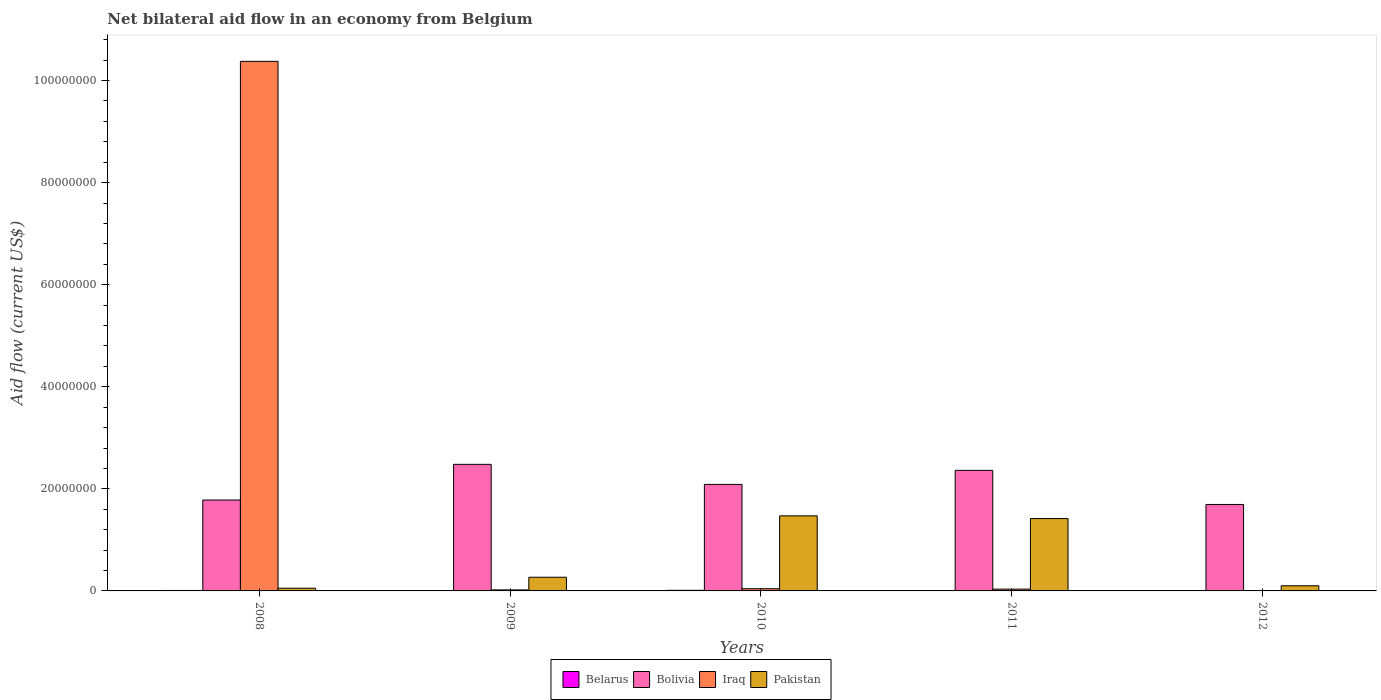How many groups of bars are there?
Provide a short and direct response. 5. Are the number of bars per tick equal to the number of legend labels?
Keep it short and to the point. Yes. Are the number of bars on each tick of the X-axis equal?
Offer a very short reply. Yes. How many bars are there on the 3rd tick from the left?
Give a very brief answer. 4. What is the net bilateral aid flow in Pakistan in 2010?
Offer a terse response. 1.47e+07. Across all years, what is the maximum net bilateral aid flow in Pakistan?
Your answer should be compact. 1.47e+07. Across all years, what is the minimum net bilateral aid flow in Pakistan?
Provide a succinct answer. 5.30e+05. In which year was the net bilateral aid flow in Belarus maximum?
Offer a terse response. 2010. What is the difference between the net bilateral aid flow in Belarus in 2008 and that in 2011?
Make the answer very short. 4.00e+04. What is the difference between the net bilateral aid flow in Bolivia in 2010 and the net bilateral aid flow in Pakistan in 2009?
Offer a terse response. 1.82e+07. What is the average net bilateral aid flow in Bolivia per year?
Give a very brief answer. 2.08e+07. In the year 2009, what is the difference between the net bilateral aid flow in Bolivia and net bilateral aid flow in Pakistan?
Give a very brief answer. 2.21e+07. In how many years, is the net bilateral aid flow in Bolivia greater than 12000000 US$?
Offer a very short reply. 5. Is the difference between the net bilateral aid flow in Bolivia in 2010 and 2012 greater than the difference between the net bilateral aid flow in Pakistan in 2010 and 2012?
Your answer should be compact. No. What is the difference between the highest and the second highest net bilateral aid flow in Pakistan?
Offer a very short reply. 5.30e+05. What is the difference between the highest and the lowest net bilateral aid flow in Pakistan?
Your answer should be compact. 1.42e+07. What does the 2nd bar from the left in 2010 represents?
Make the answer very short. Bolivia. What does the 4th bar from the right in 2009 represents?
Your response must be concise. Belarus. Is it the case that in every year, the sum of the net bilateral aid flow in Belarus and net bilateral aid flow in Bolivia is greater than the net bilateral aid flow in Pakistan?
Your answer should be compact. Yes. How many bars are there?
Your response must be concise. 20. Are all the bars in the graph horizontal?
Make the answer very short. No. How many years are there in the graph?
Offer a very short reply. 5. Does the graph contain grids?
Give a very brief answer. No. Where does the legend appear in the graph?
Your answer should be compact. Bottom center. How many legend labels are there?
Give a very brief answer. 4. What is the title of the graph?
Ensure brevity in your answer.  Net bilateral aid flow in an economy from Belgium. What is the label or title of the X-axis?
Make the answer very short. Years. What is the Aid flow (current US$) of Bolivia in 2008?
Offer a very short reply. 1.78e+07. What is the Aid flow (current US$) in Iraq in 2008?
Provide a short and direct response. 1.04e+08. What is the Aid flow (current US$) of Pakistan in 2008?
Keep it short and to the point. 5.30e+05. What is the Aid flow (current US$) in Bolivia in 2009?
Ensure brevity in your answer.  2.48e+07. What is the Aid flow (current US$) in Pakistan in 2009?
Offer a very short reply. 2.68e+06. What is the Aid flow (current US$) in Bolivia in 2010?
Your answer should be very brief. 2.09e+07. What is the Aid flow (current US$) of Iraq in 2010?
Your response must be concise. 4.30e+05. What is the Aid flow (current US$) of Pakistan in 2010?
Your response must be concise. 1.47e+07. What is the Aid flow (current US$) of Bolivia in 2011?
Keep it short and to the point. 2.36e+07. What is the Aid flow (current US$) in Iraq in 2011?
Keep it short and to the point. 3.50e+05. What is the Aid flow (current US$) of Pakistan in 2011?
Your answer should be very brief. 1.42e+07. What is the Aid flow (current US$) in Belarus in 2012?
Your answer should be very brief. 6.00e+04. What is the Aid flow (current US$) of Bolivia in 2012?
Provide a succinct answer. 1.69e+07. What is the Aid flow (current US$) of Pakistan in 2012?
Make the answer very short. 1.01e+06. Across all years, what is the maximum Aid flow (current US$) of Bolivia?
Your answer should be very brief. 2.48e+07. Across all years, what is the maximum Aid flow (current US$) in Iraq?
Ensure brevity in your answer.  1.04e+08. Across all years, what is the maximum Aid flow (current US$) of Pakistan?
Offer a very short reply. 1.47e+07. Across all years, what is the minimum Aid flow (current US$) in Bolivia?
Your answer should be compact. 1.69e+07. Across all years, what is the minimum Aid flow (current US$) of Pakistan?
Ensure brevity in your answer.  5.30e+05. What is the total Aid flow (current US$) of Belarus in the graph?
Provide a short and direct response. 3.50e+05. What is the total Aid flow (current US$) of Bolivia in the graph?
Your answer should be very brief. 1.04e+08. What is the total Aid flow (current US$) of Iraq in the graph?
Ensure brevity in your answer.  1.05e+08. What is the total Aid flow (current US$) in Pakistan in the graph?
Your response must be concise. 3.31e+07. What is the difference between the Aid flow (current US$) of Belarus in 2008 and that in 2009?
Give a very brief answer. 6.00e+04. What is the difference between the Aid flow (current US$) of Bolivia in 2008 and that in 2009?
Give a very brief answer. -6.99e+06. What is the difference between the Aid flow (current US$) in Iraq in 2008 and that in 2009?
Provide a succinct answer. 1.04e+08. What is the difference between the Aid flow (current US$) in Pakistan in 2008 and that in 2009?
Ensure brevity in your answer.  -2.15e+06. What is the difference between the Aid flow (current US$) in Belarus in 2008 and that in 2010?
Provide a short and direct response. -3.00e+04. What is the difference between the Aid flow (current US$) in Bolivia in 2008 and that in 2010?
Give a very brief answer. -3.06e+06. What is the difference between the Aid flow (current US$) in Iraq in 2008 and that in 2010?
Offer a terse response. 1.03e+08. What is the difference between the Aid flow (current US$) in Pakistan in 2008 and that in 2010?
Ensure brevity in your answer.  -1.42e+07. What is the difference between the Aid flow (current US$) in Bolivia in 2008 and that in 2011?
Keep it short and to the point. -5.81e+06. What is the difference between the Aid flow (current US$) in Iraq in 2008 and that in 2011?
Your response must be concise. 1.03e+08. What is the difference between the Aid flow (current US$) of Pakistan in 2008 and that in 2011?
Provide a succinct answer. -1.36e+07. What is the difference between the Aid flow (current US$) of Belarus in 2008 and that in 2012?
Keep it short and to the point. 3.00e+04. What is the difference between the Aid flow (current US$) in Bolivia in 2008 and that in 2012?
Provide a short and direct response. 8.70e+05. What is the difference between the Aid flow (current US$) in Iraq in 2008 and that in 2012?
Ensure brevity in your answer.  1.04e+08. What is the difference between the Aid flow (current US$) of Pakistan in 2008 and that in 2012?
Ensure brevity in your answer.  -4.80e+05. What is the difference between the Aid flow (current US$) of Belarus in 2009 and that in 2010?
Offer a terse response. -9.00e+04. What is the difference between the Aid flow (current US$) in Bolivia in 2009 and that in 2010?
Offer a terse response. 3.93e+06. What is the difference between the Aid flow (current US$) of Pakistan in 2009 and that in 2010?
Offer a very short reply. -1.20e+07. What is the difference between the Aid flow (current US$) in Bolivia in 2009 and that in 2011?
Your answer should be compact. 1.18e+06. What is the difference between the Aid flow (current US$) in Pakistan in 2009 and that in 2011?
Make the answer very short. -1.15e+07. What is the difference between the Aid flow (current US$) in Belarus in 2009 and that in 2012?
Make the answer very short. -3.00e+04. What is the difference between the Aid flow (current US$) of Bolivia in 2009 and that in 2012?
Provide a short and direct response. 7.86e+06. What is the difference between the Aid flow (current US$) of Pakistan in 2009 and that in 2012?
Offer a very short reply. 1.67e+06. What is the difference between the Aid flow (current US$) in Bolivia in 2010 and that in 2011?
Offer a very short reply. -2.75e+06. What is the difference between the Aid flow (current US$) of Pakistan in 2010 and that in 2011?
Ensure brevity in your answer.  5.30e+05. What is the difference between the Aid flow (current US$) of Belarus in 2010 and that in 2012?
Provide a short and direct response. 6.00e+04. What is the difference between the Aid flow (current US$) in Bolivia in 2010 and that in 2012?
Offer a terse response. 3.93e+06. What is the difference between the Aid flow (current US$) of Iraq in 2010 and that in 2012?
Ensure brevity in your answer.  4.00e+05. What is the difference between the Aid flow (current US$) in Pakistan in 2010 and that in 2012?
Give a very brief answer. 1.37e+07. What is the difference between the Aid flow (current US$) in Bolivia in 2011 and that in 2012?
Provide a succinct answer. 6.68e+06. What is the difference between the Aid flow (current US$) in Iraq in 2011 and that in 2012?
Provide a short and direct response. 3.20e+05. What is the difference between the Aid flow (current US$) of Pakistan in 2011 and that in 2012?
Give a very brief answer. 1.32e+07. What is the difference between the Aid flow (current US$) of Belarus in 2008 and the Aid flow (current US$) of Bolivia in 2009?
Offer a terse response. -2.47e+07. What is the difference between the Aid flow (current US$) of Belarus in 2008 and the Aid flow (current US$) of Iraq in 2009?
Ensure brevity in your answer.  -1.10e+05. What is the difference between the Aid flow (current US$) in Belarus in 2008 and the Aid flow (current US$) in Pakistan in 2009?
Offer a very short reply. -2.59e+06. What is the difference between the Aid flow (current US$) of Bolivia in 2008 and the Aid flow (current US$) of Iraq in 2009?
Your answer should be compact. 1.76e+07. What is the difference between the Aid flow (current US$) in Bolivia in 2008 and the Aid flow (current US$) in Pakistan in 2009?
Make the answer very short. 1.51e+07. What is the difference between the Aid flow (current US$) of Iraq in 2008 and the Aid flow (current US$) of Pakistan in 2009?
Make the answer very short. 1.01e+08. What is the difference between the Aid flow (current US$) in Belarus in 2008 and the Aid flow (current US$) in Bolivia in 2010?
Give a very brief answer. -2.08e+07. What is the difference between the Aid flow (current US$) in Belarus in 2008 and the Aid flow (current US$) in Pakistan in 2010?
Provide a short and direct response. -1.46e+07. What is the difference between the Aid flow (current US$) in Bolivia in 2008 and the Aid flow (current US$) in Iraq in 2010?
Provide a succinct answer. 1.74e+07. What is the difference between the Aid flow (current US$) in Bolivia in 2008 and the Aid flow (current US$) in Pakistan in 2010?
Your answer should be very brief. 3.10e+06. What is the difference between the Aid flow (current US$) of Iraq in 2008 and the Aid flow (current US$) of Pakistan in 2010?
Provide a succinct answer. 8.90e+07. What is the difference between the Aid flow (current US$) of Belarus in 2008 and the Aid flow (current US$) of Bolivia in 2011?
Offer a very short reply. -2.35e+07. What is the difference between the Aid flow (current US$) in Belarus in 2008 and the Aid flow (current US$) in Iraq in 2011?
Keep it short and to the point. -2.60e+05. What is the difference between the Aid flow (current US$) of Belarus in 2008 and the Aid flow (current US$) of Pakistan in 2011?
Make the answer very short. -1.41e+07. What is the difference between the Aid flow (current US$) in Bolivia in 2008 and the Aid flow (current US$) in Iraq in 2011?
Ensure brevity in your answer.  1.75e+07. What is the difference between the Aid flow (current US$) in Bolivia in 2008 and the Aid flow (current US$) in Pakistan in 2011?
Your answer should be very brief. 3.63e+06. What is the difference between the Aid flow (current US$) of Iraq in 2008 and the Aid flow (current US$) of Pakistan in 2011?
Offer a very short reply. 8.96e+07. What is the difference between the Aid flow (current US$) in Belarus in 2008 and the Aid flow (current US$) in Bolivia in 2012?
Provide a succinct answer. -1.68e+07. What is the difference between the Aid flow (current US$) of Belarus in 2008 and the Aid flow (current US$) of Iraq in 2012?
Give a very brief answer. 6.00e+04. What is the difference between the Aid flow (current US$) of Belarus in 2008 and the Aid flow (current US$) of Pakistan in 2012?
Provide a short and direct response. -9.20e+05. What is the difference between the Aid flow (current US$) in Bolivia in 2008 and the Aid flow (current US$) in Iraq in 2012?
Make the answer very short. 1.78e+07. What is the difference between the Aid flow (current US$) in Bolivia in 2008 and the Aid flow (current US$) in Pakistan in 2012?
Provide a short and direct response. 1.68e+07. What is the difference between the Aid flow (current US$) of Iraq in 2008 and the Aid flow (current US$) of Pakistan in 2012?
Provide a short and direct response. 1.03e+08. What is the difference between the Aid flow (current US$) in Belarus in 2009 and the Aid flow (current US$) in Bolivia in 2010?
Keep it short and to the point. -2.08e+07. What is the difference between the Aid flow (current US$) of Belarus in 2009 and the Aid flow (current US$) of Iraq in 2010?
Ensure brevity in your answer.  -4.00e+05. What is the difference between the Aid flow (current US$) of Belarus in 2009 and the Aid flow (current US$) of Pakistan in 2010?
Ensure brevity in your answer.  -1.47e+07. What is the difference between the Aid flow (current US$) of Bolivia in 2009 and the Aid flow (current US$) of Iraq in 2010?
Give a very brief answer. 2.44e+07. What is the difference between the Aid flow (current US$) of Bolivia in 2009 and the Aid flow (current US$) of Pakistan in 2010?
Provide a succinct answer. 1.01e+07. What is the difference between the Aid flow (current US$) of Iraq in 2009 and the Aid flow (current US$) of Pakistan in 2010?
Provide a succinct answer. -1.45e+07. What is the difference between the Aid flow (current US$) in Belarus in 2009 and the Aid flow (current US$) in Bolivia in 2011?
Make the answer very short. -2.36e+07. What is the difference between the Aid flow (current US$) of Belarus in 2009 and the Aid flow (current US$) of Iraq in 2011?
Offer a terse response. -3.20e+05. What is the difference between the Aid flow (current US$) of Belarus in 2009 and the Aid flow (current US$) of Pakistan in 2011?
Your answer should be very brief. -1.42e+07. What is the difference between the Aid flow (current US$) of Bolivia in 2009 and the Aid flow (current US$) of Iraq in 2011?
Your answer should be compact. 2.44e+07. What is the difference between the Aid flow (current US$) of Bolivia in 2009 and the Aid flow (current US$) of Pakistan in 2011?
Provide a succinct answer. 1.06e+07. What is the difference between the Aid flow (current US$) of Iraq in 2009 and the Aid flow (current US$) of Pakistan in 2011?
Give a very brief answer. -1.40e+07. What is the difference between the Aid flow (current US$) of Belarus in 2009 and the Aid flow (current US$) of Bolivia in 2012?
Provide a short and direct response. -1.69e+07. What is the difference between the Aid flow (current US$) of Belarus in 2009 and the Aid flow (current US$) of Pakistan in 2012?
Provide a short and direct response. -9.80e+05. What is the difference between the Aid flow (current US$) in Bolivia in 2009 and the Aid flow (current US$) in Iraq in 2012?
Ensure brevity in your answer.  2.48e+07. What is the difference between the Aid flow (current US$) of Bolivia in 2009 and the Aid flow (current US$) of Pakistan in 2012?
Offer a terse response. 2.38e+07. What is the difference between the Aid flow (current US$) in Iraq in 2009 and the Aid flow (current US$) in Pakistan in 2012?
Make the answer very short. -8.10e+05. What is the difference between the Aid flow (current US$) of Belarus in 2010 and the Aid flow (current US$) of Bolivia in 2011?
Ensure brevity in your answer.  -2.35e+07. What is the difference between the Aid flow (current US$) in Belarus in 2010 and the Aid flow (current US$) in Pakistan in 2011?
Offer a very short reply. -1.41e+07. What is the difference between the Aid flow (current US$) of Bolivia in 2010 and the Aid flow (current US$) of Iraq in 2011?
Keep it short and to the point. 2.05e+07. What is the difference between the Aid flow (current US$) of Bolivia in 2010 and the Aid flow (current US$) of Pakistan in 2011?
Your answer should be very brief. 6.69e+06. What is the difference between the Aid flow (current US$) of Iraq in 2010 and the Aid flow (current US$) of Pakistan in 2011?
Provide a short and direct response. -1.38e+07. What is the difference between the Aid flow (current US$) in Belarus in 2010 and the Aid flow (current US$) in Bolivia in 2012?
Offer a very short reply. -1.68e+07. What is the difference between the Aid flow (current US$) of Belarus in 2010 and the Aid flow (current US$) of Iraq in 2012?
Ensure brevity in your answer.  9.00e+04. What is the difference between the Aid flow (current US$) of Belarus in 2010 and the Aid flow (current US$) of Pakistan in 2012?
Provide a short and direct response. -8.90e+05. What is the difference between the Aid flow (current US$) of Bolivia in 2010 and the Aid flow (current US$) of Iraq in 2012?
Keep it short and to the point. 2.08e+07. What is the difference between the Aid flow (current US$) in Bolivia in 2010 and the Aid flow (current US$) in Pakistan in 2012?
Provide a short and direct response. 1.99e+07. What is the difference between the Aid flow (current US$) of Iraq in 2010 and the Aid flow (current US$) of Pakistan in 2012?
Your answer should be very brief. -5.80e+05. What is the difference between the Aid flow (current US$) of Belarus in 2011 and the Aid flow (current US$) of Bolivia in 2012?
Ensure brevity in your answer.  -1.69e+07. What is the difference between the Aid flow (current US$) of Belarus in 2011 and the Aid flow (current US$) of Iraq in 2012?
Your response must be concise. 2.00e+04. What is the difference between the Aid flow (current US$) of Belarus in 2011 and the Aid flow (current US$) of Pakistan in 2012?
Your answer should be compact. -9.60e+05. What is the difference between the Aid flow (current US$) in Bolivia in 2011 and the Aid flow (current US$) in Iraq in 2012?
Your answer should be compact. 2.36e+07. What is the difference between the Aid flow (current US$) in Bolivia in 2011 and the Aid flow (current US$) in Pakistan in 2012?
Offer a terse response. 2.26e+07. What is the difference between the Aid flow (current US$) in Iraq in 2011 and the Aid flow (current US$) in Pakistan in 2012?
Make the answer very short. -6.60e+05. What is the average Aid flow (current US$) of Bolivia per year?
Provide a succinct answer. 2.08e+07. What is the average Aid flow (current US$) in Iraq per year?
Offer a very short reply. 2.10e+07. What is the average Aid flow (current US$) in Pakistan per year?
Your response must be concise. 6.62e+06. In the year 2008, what is the difference between the Aid flow (current US$) in Belarus and Aid flow (current US$) in Bolivia?
Your response must be concise. -1.77e+07. In the year 2008, what is the difference between the Aid flow (current US$) in Belarus and Aid flow (current US$) in Iraq?
Give a very brief answer. -1.04e+08. In the year 2008, what is the difference between the Aid flow (current US$) in Belarus and Aid flow (current US$) in Pakistan?
Offer a terse response. -4.40e+05. In the year 2008, what is the difference between the Aid flow (current US$) of Bolivia and Aid flow (current US$) of Iraq?
Give a very brief answer. -8.60e+07. In the year 2008, what is the difference between the Aid flow (current US$) of Bolivia and Aid flow (current US$) of Pakistan?
Give a very brief answer. 1.73e+07. In the year 2008, what is the difference between the Aid flow (current US$) in Iraq and Aid flow (current US$) in Pakistan?
Provide a short and direct response. 1.03e+08. In the year 2009, what is the difference between the Aid flow (current US$) of Belarus and Aid flow (current US$) of Bolivia?
Your response must be concise. -2.48e+07. In the year 2009, what is the difference between the Aid flow (current US$) in Belarus and Aid flow (current US$) in Iraq?
Give a very brief answer. -1.70e+05. In the year 2009, what is the difference between the Aid flow (current US$) of Belarus and Aid flow (current US$) of Pakistan?
Provide a succinct answer. -2.65e+06. In the year 2009, what is the difference between the Aid flow (current US$) of Bolivia and Aid flow (current US$) of Iraq?
Offer a very short reply. 2.46e+07. In the year 2009, what is the difference between the Aid flow (current US$) of Bolivia and Aid flow (current US$) of Pakistan?
Offer a terse response. 2.21e+07. In the year 2009, what is the difference between the Aid flow (current US$) of Iraq and Aid flow (current US$) of Pakistan?
Your answer should be compact. -2.48e+06. In the year 2010, what is the difference between the Aid flow (current US$) of Belarus and Aid flow (current US$) of Bolivia?
Your answer should be compact. -2.08e+07. In the year 2010, what is the difference between the Aid flow (current US$) in Belarus and Aid flow (current US$) in Iraq?
Offer a very short reply. -3.10e+05. In the year 2010, what is the difference between the Aid flow (current US$) of Belarus and Aid flow (current US$) of Pakistan?
Keep it short and to the point. -1.46e+07. In the year 2010, what is the difference between the Aid flow (current US$) in Bolivia and Aid flow (current US$) in Iraq?
Provide a succinct answer. 2.04e+07. In the year 2010, what is the difference between the Aid flow (current US$) in Bolivia and Aid flow (current US$) in Pakistan?
Offer a terse response. 6.16e+06. In the year 2010, what is the difference between the Aid flow (current US$) in Iraq and Aid flow (current US$) in Pakistan?
Give a very brief answer. -1.43e+07. In the year 2011, what is the difference between the Aid flow (current US$) of Belarus and Aid flow (current US$) of Bolivia?
Offer a very short reply. -2.36e+07. In the year 2011, what is the difference between the Aid flow (current US$) of Belarus and Aid flow (current US$) of Pakistan?
Offer a terse response. -1.41e+07. In the year 2011, what is the difference between the Aid flow (current US$) of Bolivia and Aid flow (current US$) of Iraq?
Offer a very short reply. 2.33e+07. In the year 2011, what is the difference between the Aid flow (current US$) in Bolivia and Aid flow (current US$) in Pakistan?
Ensure brevity in your answer.  9.44e+06. In the year 2011, what is the difference between the Aid flow (current US$) of Iraq and Aid flow (current US$) of Pakistan?
Your response must be concise. -1.38e+07. In the year 2012, what is the difference between the Aid flow (current US$) of Belarus and Aid flow (current US$) of Bolivia?
Your answer should be very brief. -1.69e+07. In the year 2012, what is the difference between the Aid flow (current US$) in Belarus and Aid flow (current US$) in Iraq?
Give a very brief answer. 3.00e+04. In the year 2012, what is the difference between the Aid flow (current US$) of Belarus and Aid flow (current US$) of Pakistan?
Make the answer very short. -9.50e+05. In the year 2012, what is the difference between the Aid flow (current US$) of Bolivia and Aid flow (current US$) of Iraq?
Your response must be concise. 1.69e+07. In the year 2012, what is the difference between the Aid flow (current US$) in Bolivia and Aid flow (current US$) in Pakistan?
Provide a succinct answer. 1.59e+07. In the year 2012, what is the difference between the Aid flow (current US$) in Iraq and Aid flow (current US$) in Pakistan?
Provide a succinct answer. -9.80e+05. What is the ratio of the Aid flow (current US$) of Bolivia in 2008 to that in 2009?
Offer a very short reply. 0.72. What is the ratio of the Aid flow (current US$) of Iraq in 2008 to that in 2009?
Offer a very short reply. 518.8. What is the ratio of the Aid flow (current US$) in Pakistan in 2008 to that in 2009?
Provide a short and direct response. 0.2. What is the ratio of the Aid flow (current US$) of Bolivia in 2008 to that in 2010?
Provide a succinct answer. 0.85. What is the ratio of the Aid flow (current US$) in Iraq in 2008 to that in 2010?
Offer a terse response. 241.3. What is the ratio of the Aid flow (current US$) in Pakistan in 2008 to that in 2010?
Provide a short and direct response. 0.04. What is the ratio of the Aid flow (current US$) in Belarus in 2008 to that in 2011?
Provide a succinct answer. 1.8. What is the ratio of the Aid flow (current US$) in Bolivia in 2008 to that in 2011?
Offer a terse response. 0.75. What is the ratio of the Aid flow (current US$) of Iraq in 2008 to that in 2011?
Provide a short and direct response. 296.46. What is the ratio of the Aid flow (current US$) in Pakistan in 2008 to that in 2011?
Offer a terse response. 0.04. What is the ratio of the Aid flow (current US$) of Bolivia in 2008 to that in 2012?
Make the answer very short. 1.05. What is the ratio of the Aid flow (current US$) in Iraq in 2008 to that in 2012?
Make the answer very short. 3458.67. What is the ratio of the Aid flow (current US$) in Pakistan in 2008 to that in 2012?
Make the answer very short. 0.52. What is the ratio of the Aid flow (current US$) in Belarus in 2009 to that in 2010?
Keep it short and to the point. 0.25. What is the ratio of the Aid flow (current US$) of Bolivia in 2009 to that in 2010?
Ensure brevity in your answer.  1.19. What is the ratio of the Aid flow (current US$) in Iraq in 2009 to that in 2010?
Your answer should be compact. 0.47. What is the ratio of the Aid flow (current US$) of Pakistan in 2009 to that in 2010?
Keep it short and to the point. 0.18. What is the ratio of the Aid flow (current US$) of Belarus in 2009 to that in 2011?
Your answer should be very brief. 0.6. What is the ratio of the Aid flow (current US$) of Bolivia in 2009 to that in 2011?
Provide a short and direct response. 1.05. What is the ratio of the Aid flow (current US$) in Pakistan in 2009 to that in 2011?
Provide a short and direct response. 0.19. What is the ratio of the Aid flow (current US$) in Bolivia in 2009 to that in 2012?
Provide a short and direct response. 1.46. What is the ratio of the Aid flow (current US$) of Pakistan in 2009 to that in 2012?
Provide a short and direct response. 2.65. What is the ratio of the Aid flow (current US$) of Bolivia in 2010 to that in 2011?
Make the answer very short. 0.88. What is the ratio of the Aid flow (current US$) in Iraq in 2010 to that in 2011?
Provide a short and direct response. 1.23. What is the ratio of the Aid flow (current US$) in Pakistan in 2010 to that in 2011?
Your answer should be very brief. 1.04. What is the ratio of the Aid flow (current US$) in Bolivia in 2010 to that in 2012?
Keep it short and to the point. 1.23. What is the ratio of the Aid flow (current US$) of Iraq in 2010 to that in 2012?
Give a very brief answer. 14.33. What is the ratio of the Aid flow (current US$) of Pakistan in 2010 to that in 2012?
Offer a very short reply. 14.56. What is the ratio of the Aid flow (current US$) in Bolivia in 2011 to that in 2012?
Ensure brevity in your answer.  1.39. What is the ratio of the Aid flow (current US$) in Iraq in 2011 to that in 2012?
Ensure brevity in your answer.  11.67. What is the ratio of the Aid flow (current US$) of Pakistan in 2011 to that in 2012?
Give a very brief answer. 14.04. What is the difference between the highest and the second highest Aid flow (current US$) of Belarus?
Make the answer very short. 3.00e+04. What is the difference between the highest and the second highest Aid flow (current US$) of Bolivia?
Give a very brief answer. 1.18e+06. What is the difference between the highest and the second highest Aid flow (current US$) of Iraq?
Provide a short and direct response. 1.03e+08. What is the difference between the highest and the second highest Aid flow (current US$) in Pakistan?
Ensure brevity in your answer.  5.30e+05. What is the difference between the highest and the lowest Aid flow (current US$) in Belarus?
Offer a very short reply. 9.00e+04. What is the difference between the highest and the lowest Aid flow (current US$) in Bolivia?
Your response must be concise. 7.86e+06. What is the difference between the highest and the lowest Aid flow (current US$) of Iraq?
Make the answer very short. 1.04e+08. What is the difference between the highest and the lowest Aid flow (current US$) of Pakistan?
Keep it short and to the point. 1.42e+07. 